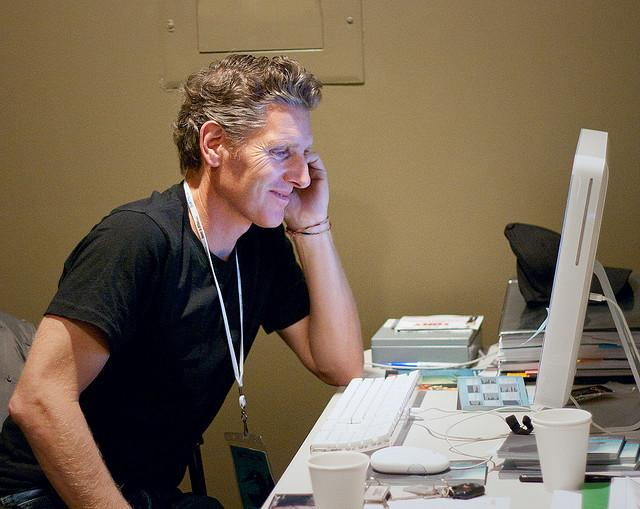What is closest to the computer screen? cup 